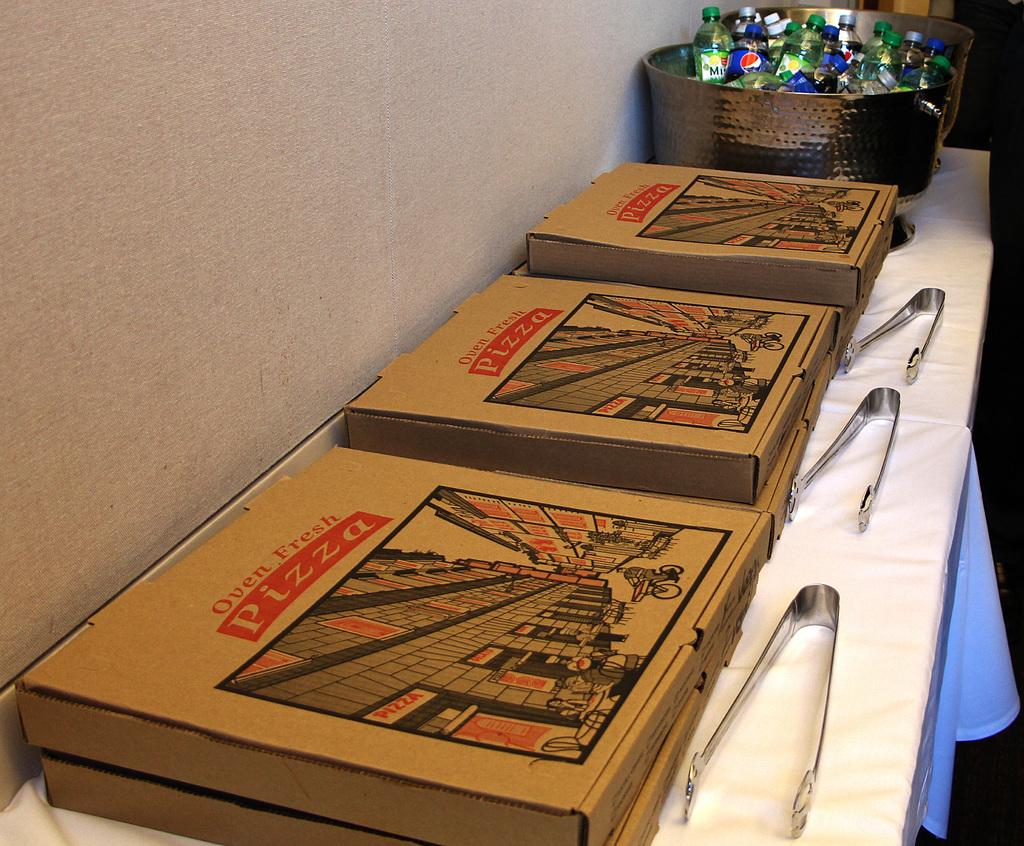What is in those boxes?
Keep it short and to the point. Pizza. What type of drink is in the green bottles?
Offer a terse response. Sierra mist. 